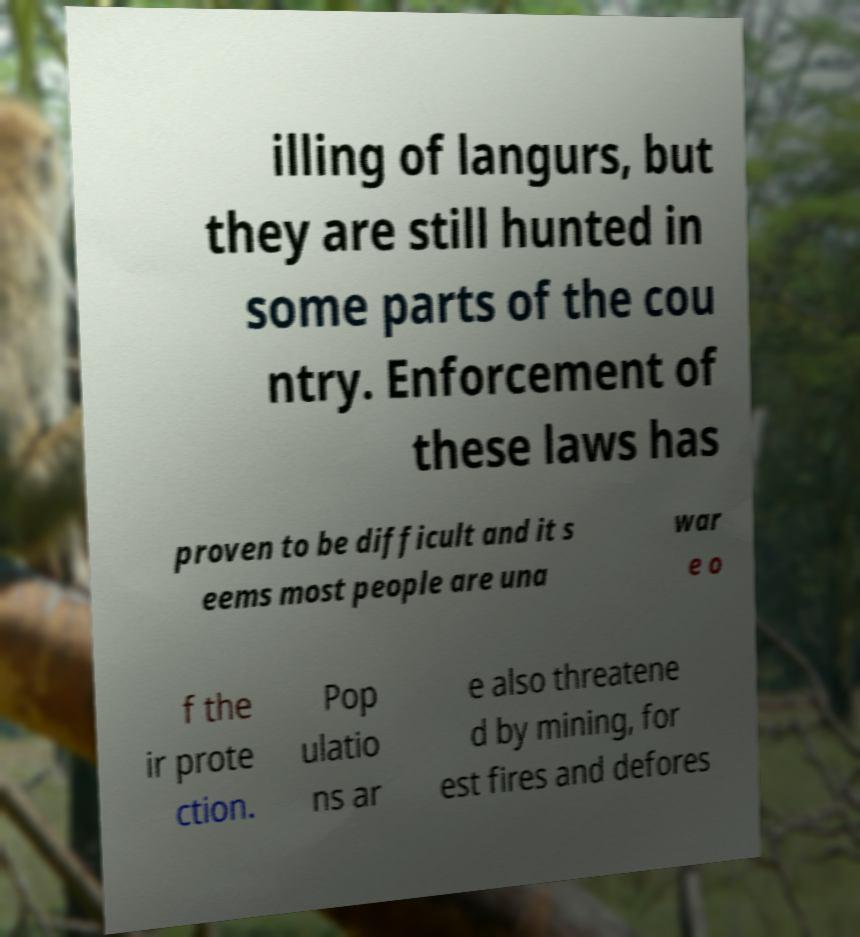Can you read and provide the text displayed in the image?This photo seems to have some interesting text. Can you extract and type it out for me? illing of langurs, but they are still hunted in some parts of the cou ntry. Enforcement of these laws has proven to be difficult and it s eems most people are una war e o f the ir prote ction. Pop ulatio ns ar e also threatene d by mining, for est fires and defores 